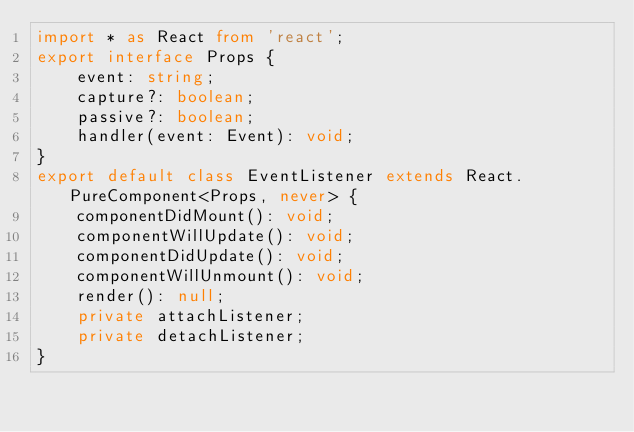Convert code to text. <code><loc_0><loc_0><loc_500><loc_500><_TypeScript_>import * as React from 'react';
export interface Props {
    event: string;
    capture?: boolean;
    passive?: boolean;
    handler(event: Event): void;
}
export default class EventListener extends React.PureComponent<Props, never> {
    componentDidMount(): void;
    componentWillUpdate(): void;
    componentDidUpdate(): void;
    componentWillUnmount(): void;
    render(): null;
    private attachListener;
    private detachListener;
}
</code> 